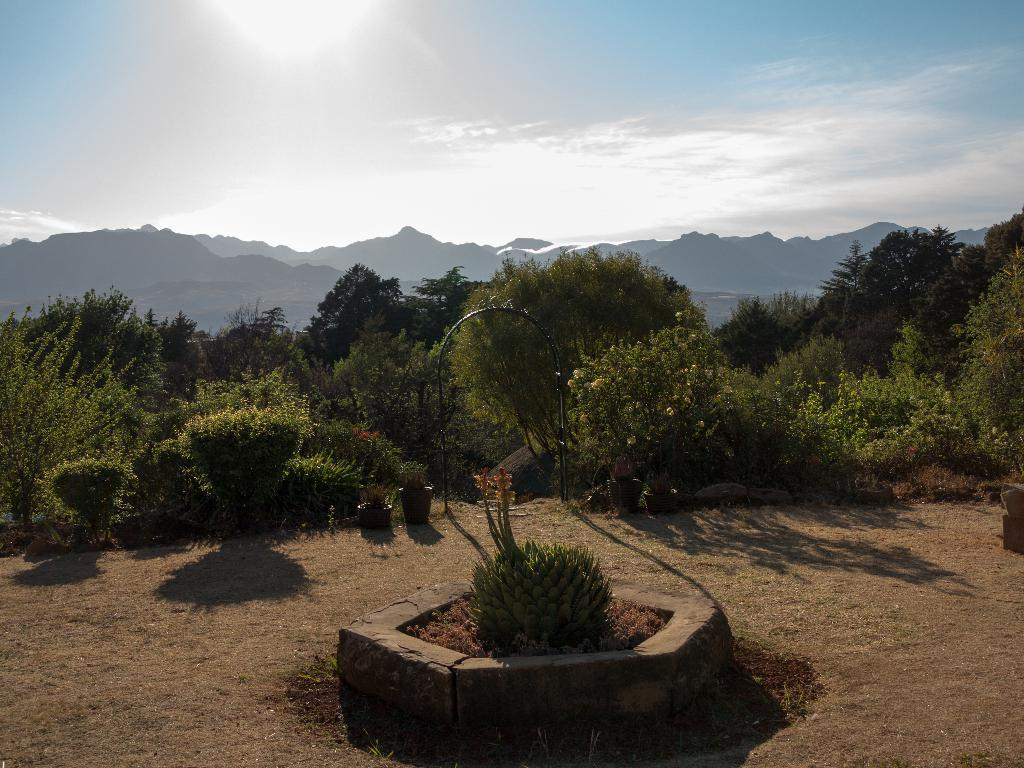What type of structure can be seen in the image? There is an arch in the image. What is located on the ground near the arch? There are potted plants on the ground. What type of vegetation is present in the image? There are trees in the image. What natural feature can be seen in the background of the image? There are mountains in the image. What is visible above the arch and trees? The sky is visible in the image. How many oranges are hanging from the arch in the image? There are no oranges present in the image; it features an arch, potted plants, trees, mountains, and the sky. 